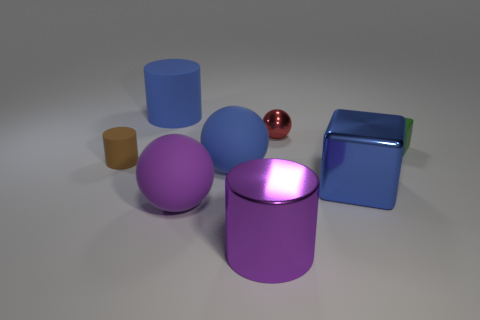Subtract all large balls. How many balls are left? 1 Add 2 yellow metallic spheres. How many objects exist? 10 Subtract all cylinders. How many objects are left? 5 Subtract all green rubber blocks. Subtract all blue rubber spheres. How many objects are left? 6 Add 6 tiny matte cylinders. How many tiny matte cylinders are left? 7 Add 6 large yellow rubber spheres. How many large yellow rubber spheres exist? 6 Subtract 0 yellow cylinders. How many objects are left? 8 Subtract all yellow balls. Subtract all purple cubes. How many balls are left? 3 